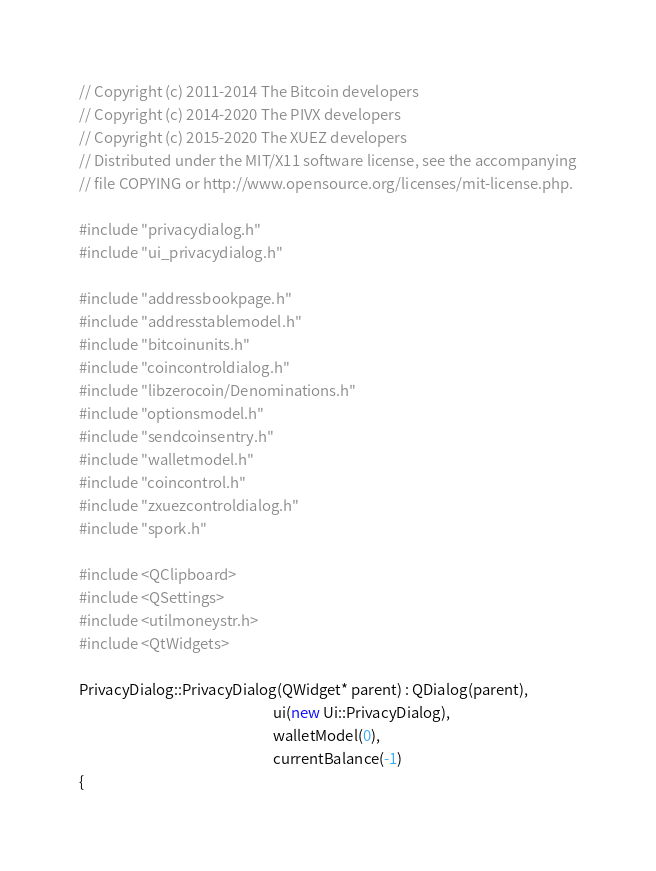<code> <loc_0><loc_0><loc_500><loc_500><_C++_>// Copyright (c) 2011-2014 The Bitcoin developers
// Copyright (c) 2014-2020 The PIVX developers    
// Copyright (c) 2015-2020 The XUEZ developers
// Distributed under the MIT/X11 software license, see the accompanying
// file COPYING or http://www.opensource.org/licenses/mit-license.php.

#include "privacydialog.h"
#include "ui_privacydialog.h"

#include "addressbookpage.h"
#include "addresstablemodel.h"
#include "bitcoinunits.h"
#include "coincontroldialog.h"
#include "libzerocoin/Denominations.h"
#include "optionsmodel.h"
#include "sendcoinsentry.h"
#include "walletmodel.h"
#include "coincontrol.h"
#include "zxuezcontroldialog.h"
#include "spork.h"

#include <QClipboard>
#include <QSettings>
#include <utilmoneystr.h>
#include <QtWidgets>

PrivacyDialog::PrivacyDialog(QWidget* parent) : QDialog(parent),
                                                          ui(new Ui::PrivacyDialog),
                                                          walletModel(0),
                                                          currentBalance(-1)
{</code> 